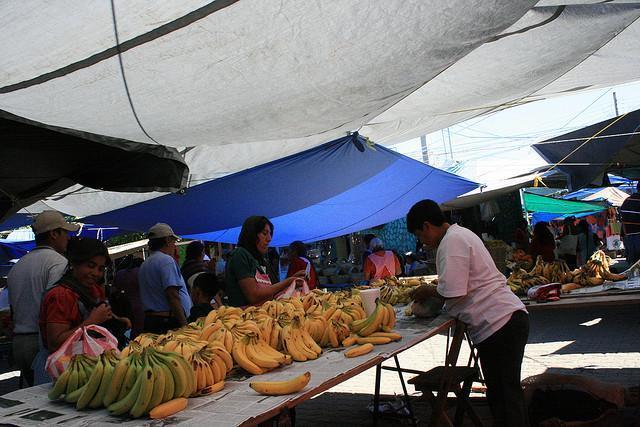How many bananas can be seen?
Give a very brief answer. 1. How many chairs can you see?
Give a very brief answer. 1. How many people can be seen?
Give a very brief answer. 5. 